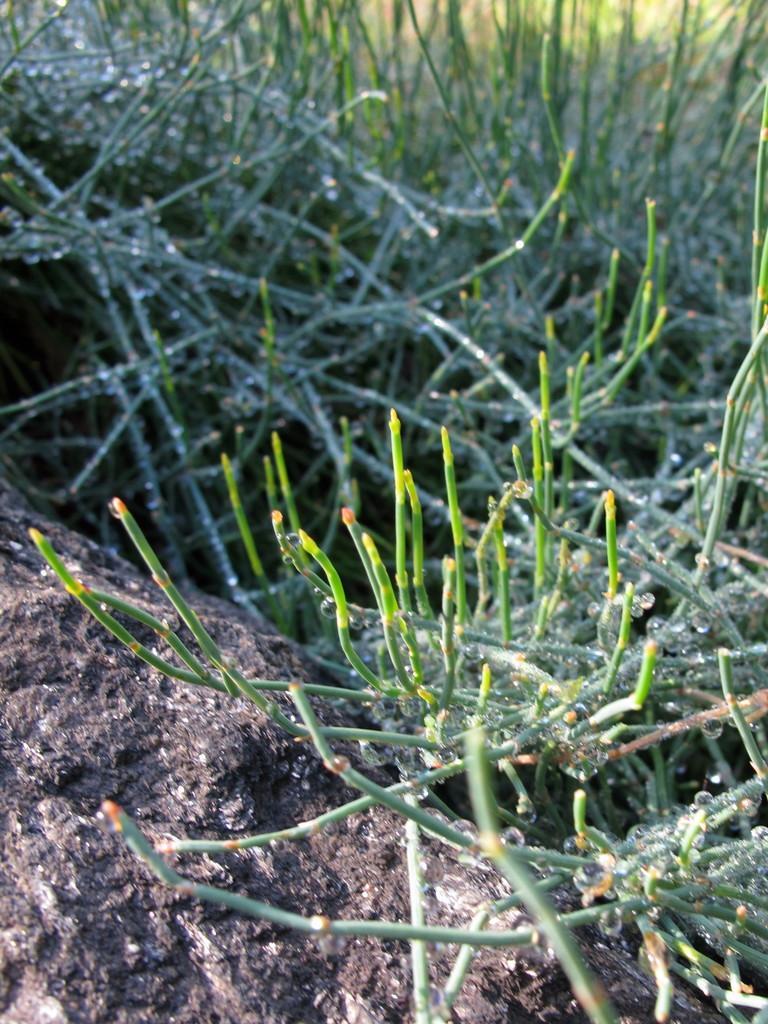How would you summarize this image in a sentence or two? In this image in front there is a rock and there are plants. 